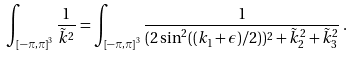Convert formula to latex. <formula><loc_0><loc_0><loc_500><loc_500>\int _ { \left [ - \pi , \pi \right ] ^ { 3 } } \frac { 1 } { \tilde { k } ^ { 2 } } = \int _ { \left [ - \pi , \pi \right ] ^ { 3 } } \frac { 1 } { ( 2 \sin ^ { 2 } ( ( k _ { 1 } + \epsilon ) / 2 ) ) ^ { 2 } + \tilde { k } _ { 2 } ^ { 2 } + \tilde { k } _ { 3 } ^ { 2 } } \, .</formula> 